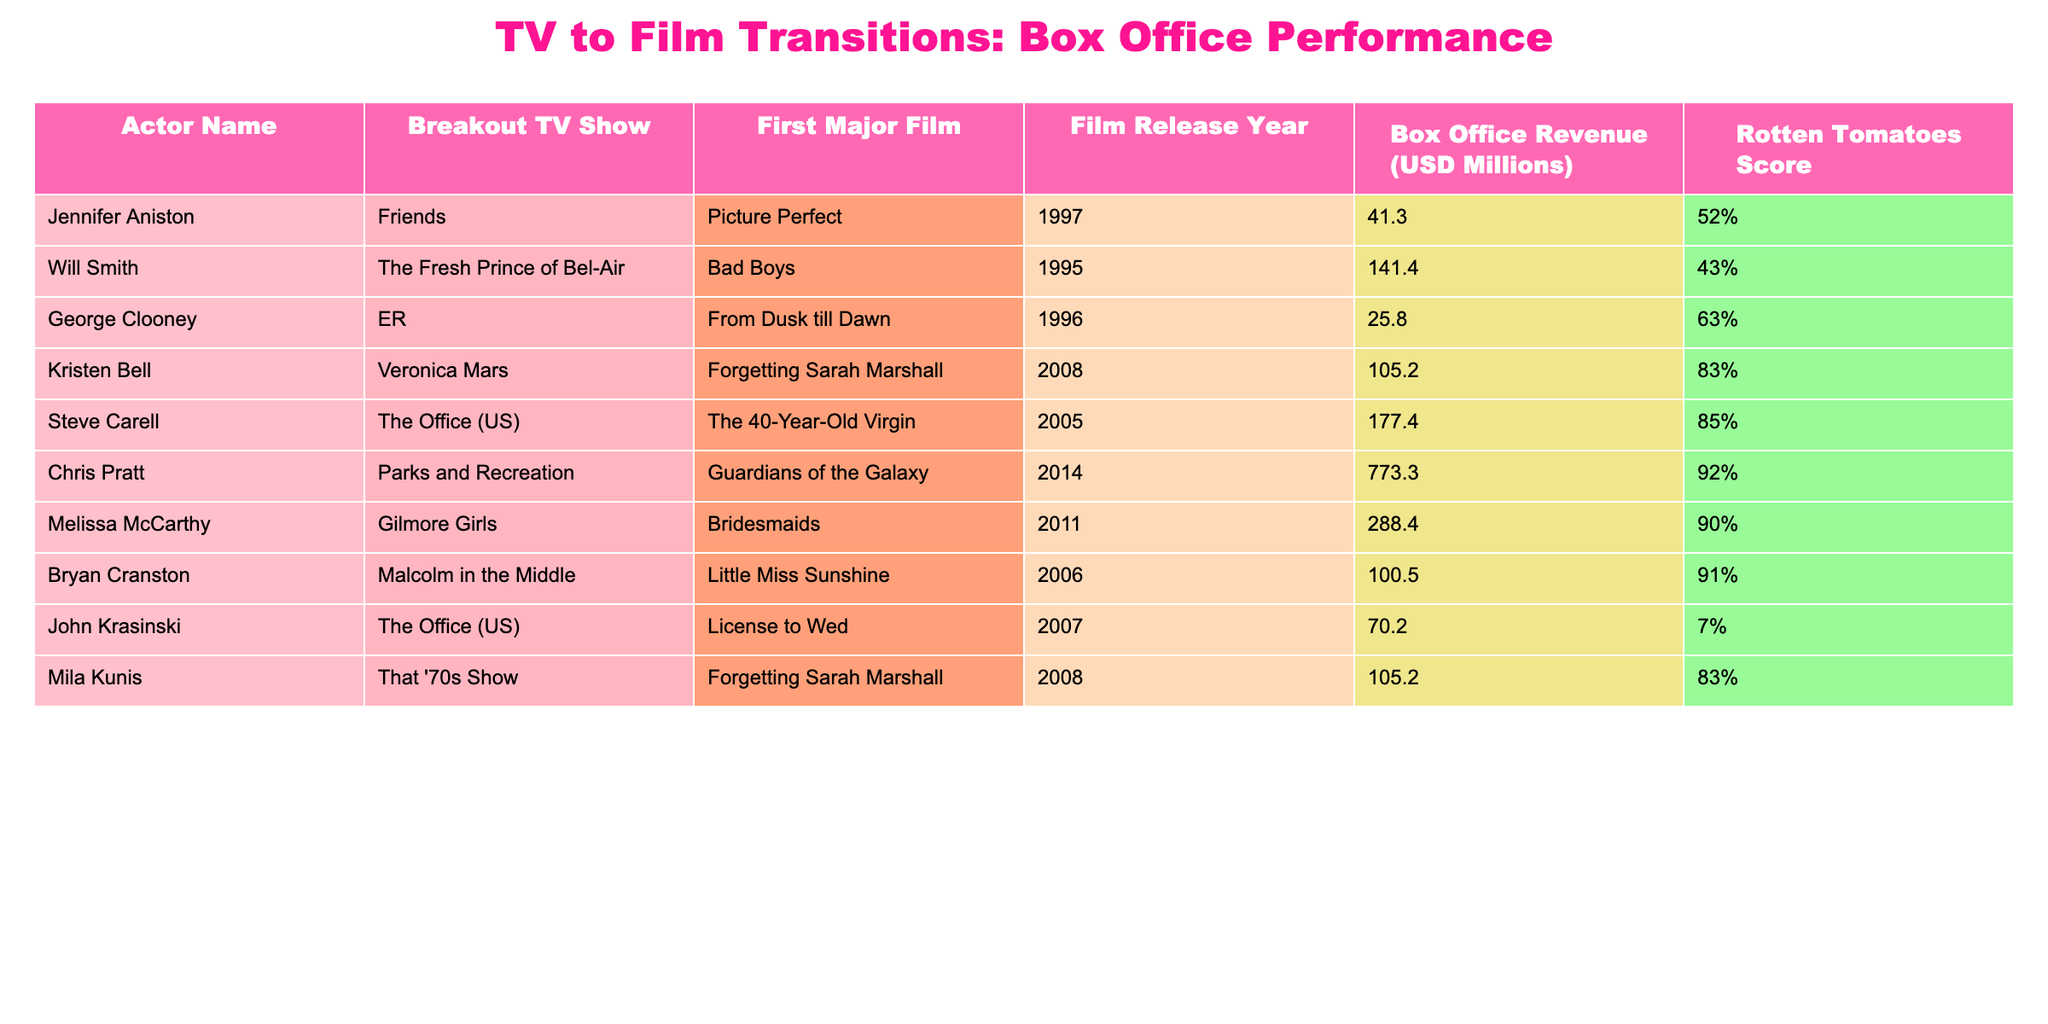What is the box office revenue of Chris Pratt's first major film? Looking at the table, Chris Pratt's first major film is "Guardians of the Galaxy," which has a box office revenue of 773.3 million USD.
Answer: 773.3 million USD Which actor transitioned from "The Office (US)" and had a film with a Rotten Tomatoes score lower than 50%? The table lists two actors from "The Office (US)": Steve Carell, whose film "The 40-Year-Old Virgin" has a score of 85%, and John Krasinski, whose film "License to Wed" has a score of 7%. Therefore, John Krasinski is the actor who fits this criterion.
Answer: John Krasinski What is the average box office revenue of actors who started from "Friends" and "Gilmore Girls"? From the table, Jennifer Aniston (41.3 million USD) and Melissa McCarthy (288.4 million USD) are the actors from "Friends" and "Gilmore Girls," respectively. The average box office revenue is (41.3 + 288.4) / 2 = 164.85 million USD.
Answer: 164.85 million USD Which actor had the highest box office revenue and what was the film title? Chris Pratt had the highest box office revenue at 773.3 million USD for his film "Guardians of the Galaxy."
Answer: Chris Pratt, "Guardians of the Galaxy" Is it true that all actors listed had box office revenues exceeding 100 million dollars? No, the data shows that both George Clooney with 25.8 million and Jennifer Aniston with 41.3 million USD had box office revenues below 100 million dollars. Thus, it is false.
Answer: False How much more did Melissa McCarthy earn in box office revenue compared to Bryan Cranston? Melissa McCarthy's box office revenue is 288.4 million USD, while Bryan Cranston's is 100.5 million USD. The difference is 288.4 - 100.5 = 187.9 million USD.
Answer: 187.9 million USD Which film had the highest Rotten Tomatoes score among the listed actors? The film "Guardians of the Galaxy" by Chris Pratt has the highest Rotten Tomatoes score of 92% among the listed films.
Answer: "Guardians of the Galaxy" What percentage of the actors have a film title that begins with the letter "F"? There are 10 actors listed, and 4 of their films start with "F" ("Forgetting Sarah Marshall" and "Forgetting Sarah Marshall," by Kristen Bell and Mila Kunis, respectively; "Friends" has "Picture Perfect"). To find the percentage: (4/10) * 100 = 40%.
Answer: 40% What was the lowest Rotten Tomatoes score and which actor had it? John Krasinski had the lowest Rotten Tomatoes score of 7% for his film "License to Wed."
Answer: 7%, John Krasinski 